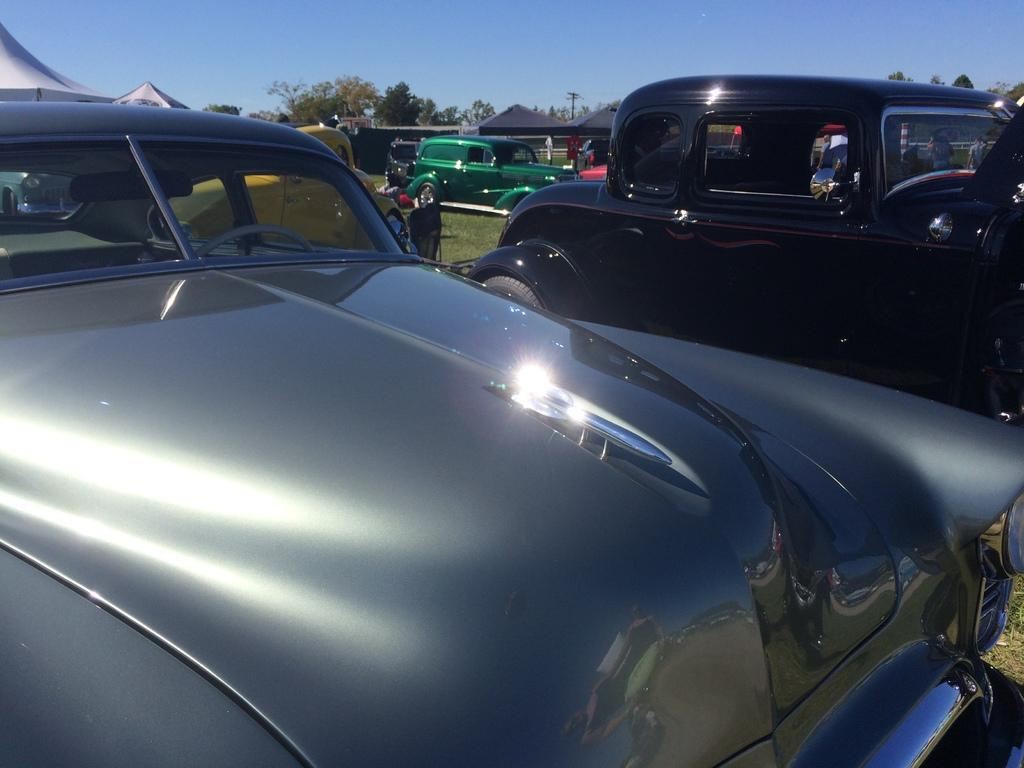What can be seen in the image? There are vehicles in the image. Can you describe the color of the front vehicle? The front vehicle is silver in color. What is present in the background of the image? There is an electric pole and trees with green color in the background of the image. What is the color of the sky in the image? The sky is blue in color. Where is the tent located in the image? There is no tent present in the image. What type of engine is used in the vehicles in the image? The provided facts do not mention the type of engine used in the vehicles, so it cannot be determined from the image. 